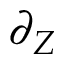Convert formula to latex. <formula><loc_0><loc_0><loc_500><loc_500>\partial _ { Z }</formula> 